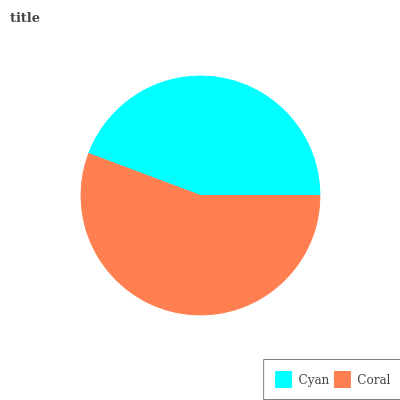Is Cyan the minimum?
Answer yes or no. Yes. Is Coral the maximum?
Answer yes or no. Yes. Is Coral the minimum?
Answer yes or no. No. Is Coral greater than Cyan?
Answer yes or no. Yes. Is Cyan less than Coral?
Answer yes or no. Yes. Is Cyan greater than Coral?
Answer yes or no. No. Is Coral less than Cyan?
Answer yes or no. No. Is Coral the high median?
Answer yes or no. Yes. Is Cyan the low median?
Answer yes or no. Yes. Is Cyan the high median?
Answer yes or no. No. Is Coral the low median?
Answer yes or no. No. 